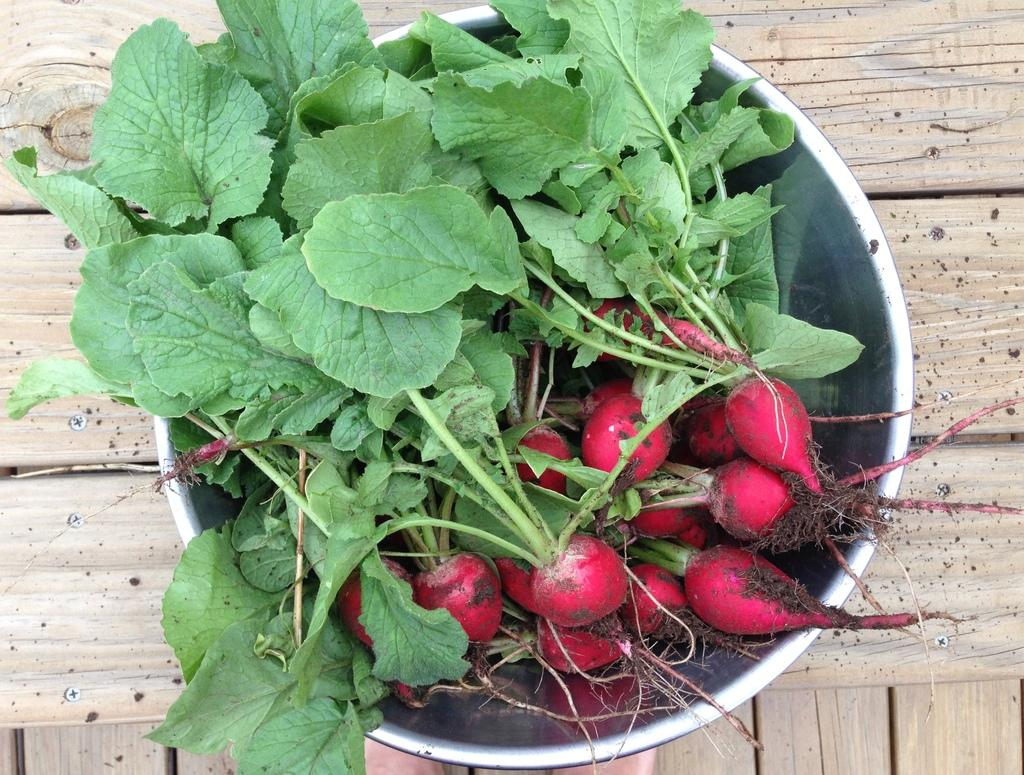What type of object is made of wood in the image? There is a wooden object in the image. What is placed on the wooden object? There is a container on the wooden object. What is inside the container? The container holds reddish and green leaves. Can you tell me how many dogs are sitting next to the wooden object in the image? There are no dogs present in the image; it only features a wooden object with a container holding reddish and green leaves. 